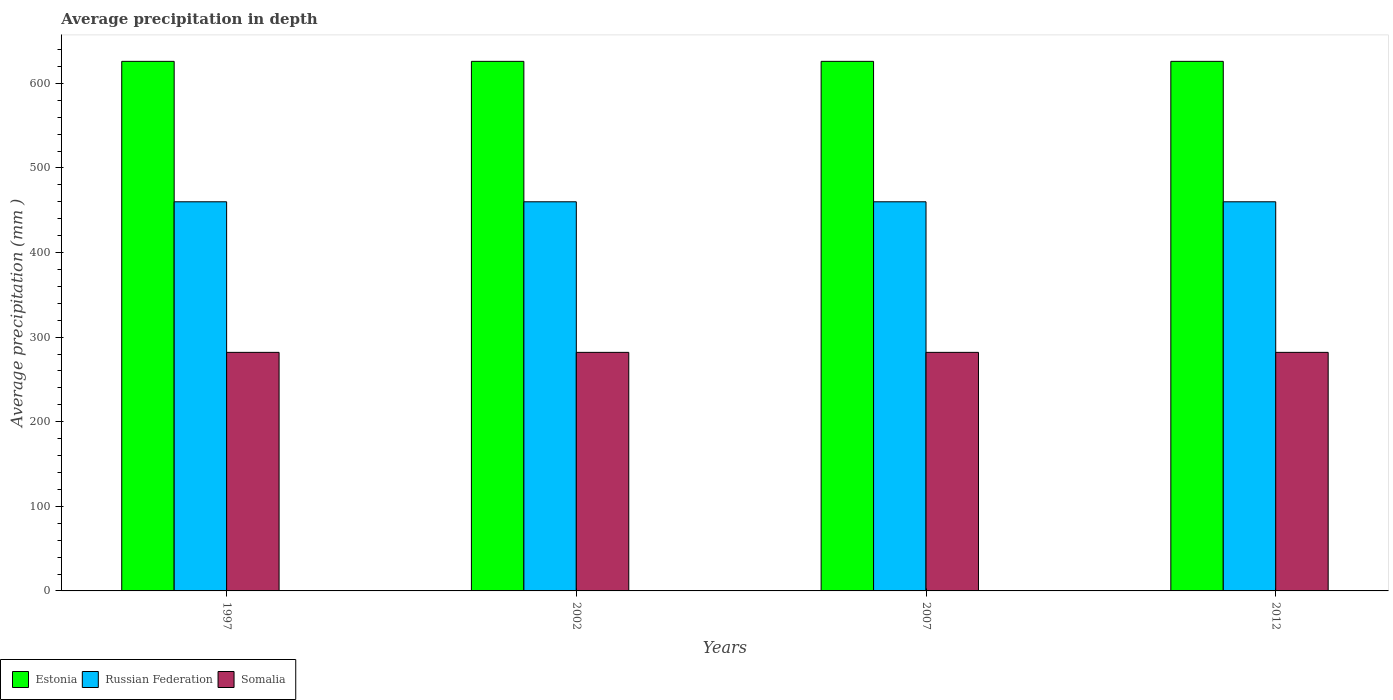How many different coloured bars are there?
Your response must be concise. 3. Are the number of bars per tick equal to the number of legend labels?
Make the answer very short. Yes. How many bars are there on the 3rd tick from the left?
Your answer should be compact. 3. What is the label of the 2nd group of bars from the left?
Give a very brief answer. 2002. What is the average precipitation in Russian Federation in 2007?
Ensure brevity in your answer.  460. Across all years, what is the maximum average precipitation in Somalia?
Keep it short and to the point. 282. Across all years, what is the minimum average precipitation in Somalia?
Your response must be concise. 282. In which year was the average precipitation in Estonia maximum?
Your answer should be compact. 1997. In which year was the average precipitation in Somalia minimum?
Give a very brief answer. 1997. What is the total average precipitation in Russian Federation in the graph?
Provide a succinct answer. 1840. What is the difference between the average precipitation in Somalia in 2007 and the average precipitation in Russian Federation in 2002?
Make the answer very short. -178. What is the average average precipitation in Russian Federation per year?
Offer a terse response. 460. In the year 2007, what is the difference between the average precipitation in Somalia and average precipitation in Estonia?
Your answer should be very brief. -344. In how many years, is the average precipitation in Russian Federation greater than 40 mm?
Ensure brevity in your answer.  4. Is the average precipitation in Estonia in 1997 less than that in 2012?
Give a very brief answer. No. Is the difference between the average precipitation in Somalia in 2002 and 2012 greater than the difference between the average precipitation in Estonia in 2002 and 2012?
Provide a short and direct response. No. In how many years, is the average precipitation in Somalia greater than the average average precipitation in Somalia taken over all years?
Provide a short and direct response. 0. Is the sum of the average precipitation in Estonia in 2002 and 2007 greater than the maximum average precipitation in Somalia across all years?
Offer a terse response. Yes. What does the 3rd bar from the left in 2002 represents?
Your answer should be compact. Somalia. What does the 2nd bar from the right in 2002 represents?
Offer a terse response. Russian Federation. Is it the case that in every year, the sum of the average precipitation in Estonia and average precipitation in Russian Federation is greater than the average precipitation in Somalia?
Your answer should be compact. Yes. How many years are there in the graph?
Your response must be concise. 4. What is the difference between two consecutive major ticks on the Y-axis?
Your answer should be very brief. 100. Are the values on the major ticks of Y-axis written in scientific E-notation?
Offer a terse response. No. Does the graph contain grids?
Keep it short and to the point. No. How many legend labels are there?
Provide a short and direct response. 3. How are the legend labels stacked?
Offer a terse response. Horizontal. What is the title of the graph?
Provide a succinct answer. Average precipitation in depth. What is the label or title of the Y-axis?
Your answer should be very brief. Average precipitation (mm ). What is the Average precipitation (mm ) of Estonia in 1997?
Provide a succinct answer. 626. What is the Average precipitation (mm ) of Russian Federation in 1997?
Your response must be concise. 460. What is the Average precipitation (mm ) of Somalia in 1997?
Offer a very short reply. 282. What is the Average precipitation (mm ) of Estonia in 2002?
Offer a terse response. 626. What is the Average precipitation (mm ) of Russian Federation in 2002?
Provide a short and direct response. 460. What is the Average precipitation (mm ) of Somalia in 2002?
Your answer should be compact. 282. What is the Average precipitation (mm ) in Estonia in 2007?
Keep it short and to the point. 626. What is the Average precipitation (mm ) in Russian Federation in 2007?
Your answer should be compact. 460. What is the Average precipitation (mm ) in Somalia in 2007?
Your response must be concise. 282. What is the Average precipitation (mm ) in Estonia in 2012?
Your answer should be very brief. 626. What is the Average precipitation (mm ) of Russian Federation in 2012?
Your response must be concise. 460. What is the Average precipitation (mm ) in Somalia in 2012?
Ensure brevity in your answer.  282. Across all years, what is the maximum Average precipitation (mm ) in Estonia?
Your response must be concise. 626. Across all years, what is the maximum Average precipitation (mm ) of Russian Federation?
Provide a succinct answer. 460. Across all years, what is the maximum Average precipitation (mm ) of Somalia?
Your answer should be compact. 282. Across all years, what is the minimum Average precipitation (mm ) in Estonia?
Offer a terse response. 626. Across all years, what is the minimum Average precipitation (mm ) of Russian Federation?
Give a very brief answer. 460. Across all years, what is the minimum Average precipitation (mm ) in Somalia?
Offer a terse response. 282. What is the total Average precipitation (mm ) in Estonia in the graph?
Offer a terse response. 2504. What is the total Average precipitation (mm ) in Russian Federation in the graph?
Keep it short and to the point. 1840. What is the total Average precipitation (mm ) in Somalia in the graph?
Offer a very short reply. 1128. What is the difference between the Average precipitation (mm ) in Russian Federation in 1997 and that in 2002?
Give a very brief answer. 0. What is the difference between the Average precipitation (mm ) of Somalia in 1997 and that in 2002?
Your answer should be very brief. 0. What is the difference between the Average precipitation (mm ) of Estonia in 1997 and that in 2007?
Offer a terse response. 0. What is the difference between the Average precipitation (mm ) in Estonia in 1997 and that in 2012?
Give a very brief answer. 0. What is the difference between the Average precipitation (mm ) in Russian Federation in 2002 and that in 2007?
Offer a terse response. 0. What is the difference between the Average precipitation (mm ) in Somalia in 2002 and that in 2007?
Give a very brief answer. 0. What is the difference between the Average precipitation (mm ) of Estonia in 2002 and that in 2012?
Keep it short and to the point. 0. What is the difference between the Average precipitation (mm ) in Russian Federation in 2002 and that in 2012?
Offer a terse response. 0. What is the difference between the Average precipitation (mm ) of Russian Federation in 2007 and that in 2012?
Provide a short and direct response. 0. What is the difference between the Average precipitation (mm ) of Estonia in 1997 and the Average precipitation (mm ) of Russian Federation in 2002?
Ensure brevity in your answer.  166. What is the difference between the Average precipitation (mm ) in Estonia in 1997 and the Average precipitation (mm ) in Somalia in 2002?
Provide a succinct answer. 344. What is the difference between the Average precipitation (mm ) in Russian Federation in 1997 and the Average precipitation (mm ) in Somalia in 2002?
Offer a very short reply. 178. What is the difference between the Average precipitation (mm ) in Estonia in 1997 and the Average precipitation (mm ) in Russian Federation in 2007?
Make the answer very short. 166. What is the difference between the Average precipitation (mm ) in Estonia in 1997 and the Average precipitation (mm ) in Somalia in 2007?
Keep it short and to the point. 344. What is the difference between the Average precipitation (mm ) of Russian Federation in 1997 and the Average precipitation (mm ) of Somalia in 2007?
Offer a terse response. 178. What is the difference between the Average precipitation (mm ) of Estonia in 1997 and the Average precipitation (mm ) of Russian Federation in 2012?
Ensure brevity in your answer.  166. What is the difference between the Average precipitation (mm ) of Estonia in 1997 and the Average precipitation (mm ) of Somalia in 2012?
Provide a succinct answer. 344. What is the difference between the Average precipitation (mm ) of Russian Federation in 1997 and the Average precipitation (mm ) of Somalia in 2012?
Ensure brevity in your answer.  178. What is the difference between the Average precipitation (mm ) in Estonia in 2002 and the Average precipitation (mm ) in Russian Federation in 2007?
Offer a terse response. 166. What is the difference between the Average precipitation (mm ) in Estonia in 2002 and the Average precipitation (mm ) in Somalia in 2007?
Offer a terse response. 344. What is the difference between the Average precipitation (mm ) in Russian Federation in 2002 and the Average precipitation (mm ) in Somalia in 2007?
Your response must be concise. 178. What is the difference between the Average precipitation (mm ) in Estonia in 2002 and the Average precipitation (mm ) in Russian Federation in 2012?
Keep it short and to the point. 166. What is the difference between the Average precipitation (mm ) in Estonia in 2002 and the Average precipitation (mm ) in Somalia in 2012?
Ensure brevity in your answer.  344. What is the difference between the Average precipitation (mm ) of Russian Federation in 2002 and the Average precipitation (mm ) of Somalia in 2012?
Provide a short and direct response. 178. What is the difference between the Average precipitation (mm ) in Estonia in 2007 and the Average precipitation (mm ) in Russian Federation in 2012?
Offer a terse response. 166. What is the difference between the Average precipitation (mm ) of Estonia in 2007 and the Average precipitation (mm ) of Somalia in 2012?
Provide a short and direct response. 344. What is the difference between the Average precipitation (mm ) in Russian Federation in 2007 and the Average precipitation (mm ) in Somalia in 2012?
Offer a very short reply. 178. What is the average Average precipitation (mm ) in Estonia per year?
Your response must be concise. 626. What is the average Average precipitation (mm ) of Russian Federation per year?
Provide a short and direct response. 460. What is the average Average precipitation (mm ) in Somalia per year?
Offer a very short reply. 282. In the year 1997, what is the difference between the Average precipitation (mm ) in Estonia and Average precipitation (mm ) in Russian Federation?
Make the answer very short. 166. In the year 1997, what is the difference between the Average precipitation (mm ) of Estonia and Average precipitation (mm ) of Somalia?
Offer a terse response. 344. In the year 1997, what is the difference between the Average precipitation (mm ) in Russian Federation and Average precipitation (mm ) in Somalia?
Make the answer very short. 178. In the year 2002, what is the difference between the Average precipitation (mm ) of Estonia and Average precipitation (mm ) of Russian Federation?
Your response must be concise. 166. In the year 2002, what is the difference between the Average precipitation (mm ) of Estonia and Average precipitation (mm ) of Somalia?
Ensure brevity in your answer.  344. In the year 2002, what is the difference between the Average precipitation (mm ) of Russian Federation and Average precipitation (mm ) of Somalia?
Make the answer very short. 178. In the year 2007, what is the difference between the Average precipitation (mm ) of Estonia and Average precipitation (mm ) of Russian Federation?
Provide a short and direct response. 166. In the year 2007, what is the difference between the Average precipitation (mm ) in Estonia and Average precipitation (mm ) in Somalia?
Make the answer very short. 344. In the year 2007, what is the difference between the Average precipitation (mm ) of Russian Federation and Average precipitation (mm ) of Somalia?
Make the answer very short. 178. In the year 2012, what is the difference between the Average precipitation (mm ) in Estonia and Average precipitation (mm ) in Russian Federation?
Make the answer very short. 166. In the year 2012, what is the difference between the Average precipitation (mm ) of Estonia and Average precipitation (mm ) of Somalia?
Offer a very short reply. 344. In the year 2012, what is the difference between the Average precipitation (mm ) of Russian Federation and Average precipitation (mm ) of Somalia?
Offer a terse response. 178. What is the ratio of the Average precipitation (mm ) of Estonia in 1997 to that in 2002?
Provide a succinct answer. 1. What is the ratio of the Average precipitation (mm ) in Somalia in 1997 to that in 2002?
Ensure brevity in your answer.  1. What is the ratio of the Average precipitation (mm ) in Russian Federation in 1997 to that in 2007?
Provide a succinct answer. 1. What is the ratio of the Average precipitation (mm ) in Somalia in 1997 to that in 2007?
Your answer should be very brief. 1. What is the ratio of the Average precipitation (mm ) in Russian Federation in 1997 to that in 2012?
Offer a very short reply. 1. What is the ratio of the Average precipitation (mm ) in Somalia in 1997 to that in 2012?
Offer a terse response. 1. What is the ratio of the Average precipitation (mm ) of Russian Federation in 2002 to that in 2007?
Give a very brief answer. 1. What is the ratio of the Average precipitation (mm ) of Somalia in 2002 to that in 2007?
Your answer should be very brief. 1. What is the ratio of the Average precipitation (mm ) of Estonia in 2002 to that in 2012?
Your response must be concise. 1. What is the ratio of the Average precipitation (mm ) in Russian Federation in 2002 to that in 2012?
Your answer should be compact. 1. What is the ratio of the Average precipitation (mm ) in Somalia in 2002 to that in 2012?
Give a very brief answer. 1. What is the difference between the highest and the second highest Average precipitation (mm ) of Estonia?
Provide a short and direct response. 0. What is the difference between the highest and the lowest Average precipitation (mm ) of Estonia?
Your answer should be compact. 0. What is the difference between the highest and the lowest Average precipitation (mm ) of Russian Federation?
Offer a terse response. 0. 